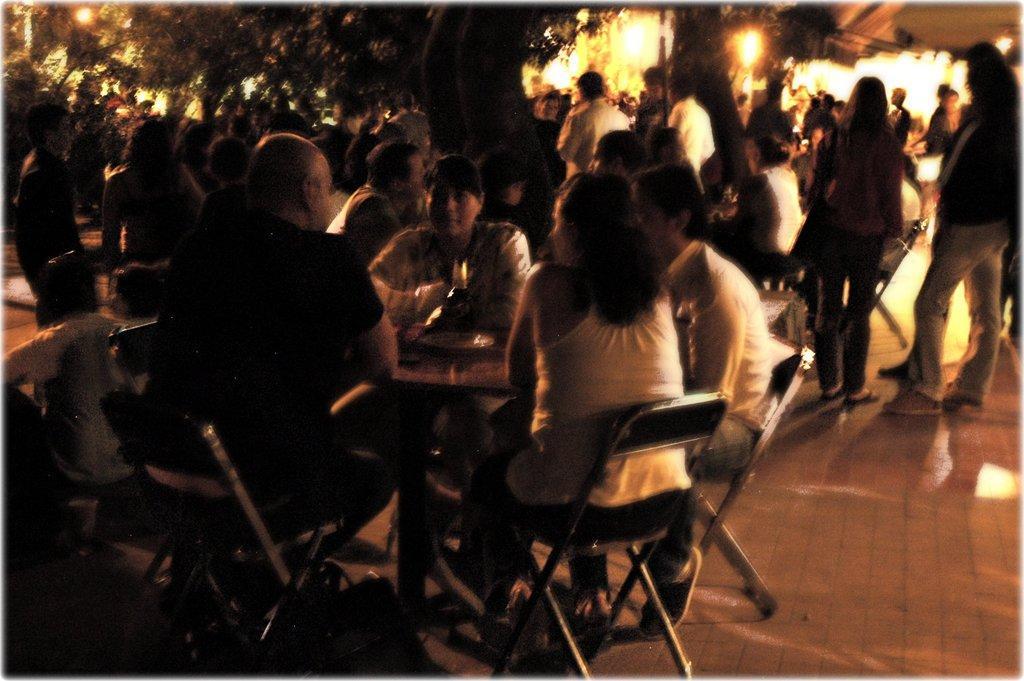In one or two sentences, can you explain what this image depicts? In this image there are some persons sitting on the chairs in the bottom of this image and there are some persons in the background. There are some trees on the top of this image. 